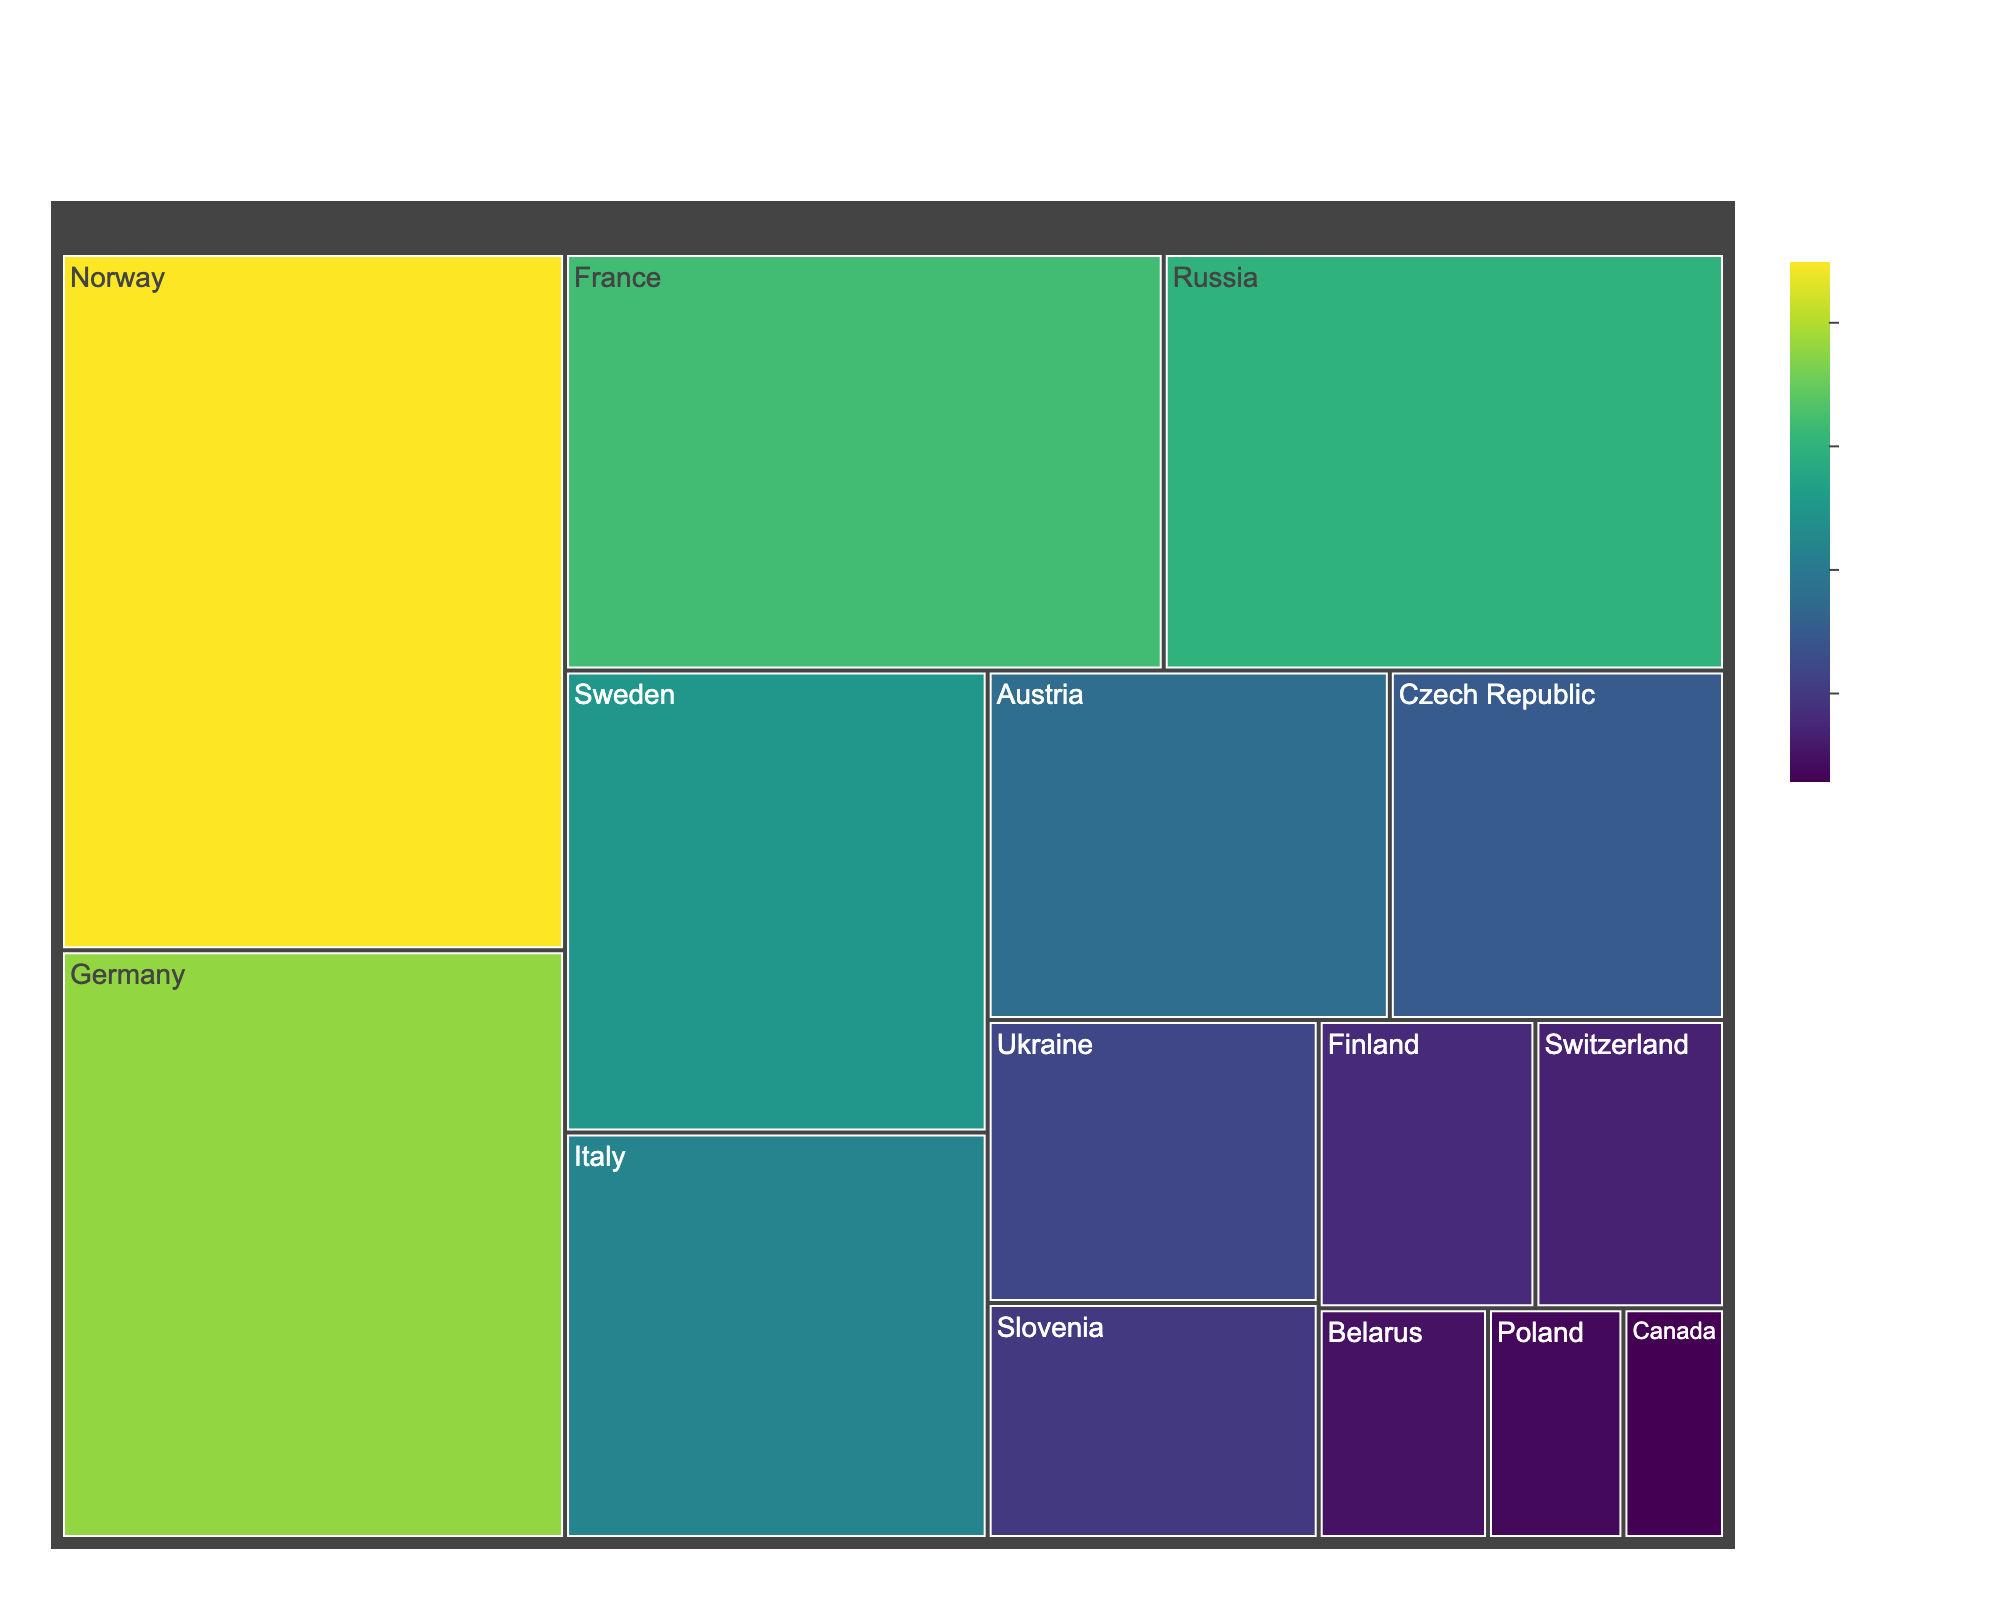What is the country with the highest number of total medals? Observe the Treemap and look for the country segment with the largest area, which will represent the country with the most medals. Norway appears to have the largest segment.
Answer: Norway How many gold medals has Germany won? Hover over Germany's segment in the Treemap to see the detailed breakdown of medal types. Germany has won 18 gold medals.
Answer: 18 Which country has the fewest total medals and how many? Check the smallest segment in the Treemap. The smallest segment corresponds to Canada, which has the fewest total medals. Canada has won 3 medals.
Answer: Canada, 3 Which country has more silver medals, Sweden or Italy? Hover over the segments for Sweden and Italy and compare the number of silver medals. Sweden has 9 silver medals while Italy has 8.
Answer: Sweden What is the total number of bronze medals won by all countries combined? Sum the total number of bronze medals from each country's breakdown: 10 + 8 + 10 + 9 + 8 + 7 + 7 + 6 + 5 + 5 + 3 + 4 + 2 + 2 + 1 = 87
Answer: 87 Which country has a closer medal count to Slovenia, Austria or Czech Republic? Compare the total medals of Austria (18), Czech Republic (15), and Slovenia (10). Slovenia is closer to Czech Republic since 10 is nearer to 15 than to 18.
Answer: Czech Republic How many countries have won at least 20 medals in total? Scan the Treemap for countries whose segments show a total medal count of 20 or more. The countries are Norway, Germany, France, Russia, Sweden, and Italy. There are 6 countries.
Answer: 6 What percentage of total medals are won by Norway? First, calculate the total number of medals from all countries, then find Norway's share: Total medals = 45 + 38 + 32 + 30 + 25 + 22 + 18 + 15 + 12 + 10 + 8 + 7 + 5 + 4 + 3 = 274. Norway's percentage = (45 / 274) * 100 ≈ 16.42%
Answer: ~16.42% Which country has more combined gold and bronze medals, France or Russia? Add the gold and bronze medals for both countries and compare them. France: 12 Gold + 10 Bronze = 22, Russia: 10 Gold + 9 Bronze = 19.
Answer: France 